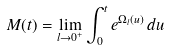Convert formula to latex. <formula><loc_0><loc_0><loc_500><loc_500>M ( t ) = \lim _ { l \rightarrow 0 ^ { + } } \int _ { 0 } ^ { t } e ^ { \Omega _ { l } ( u ) } \, d u</formula> 